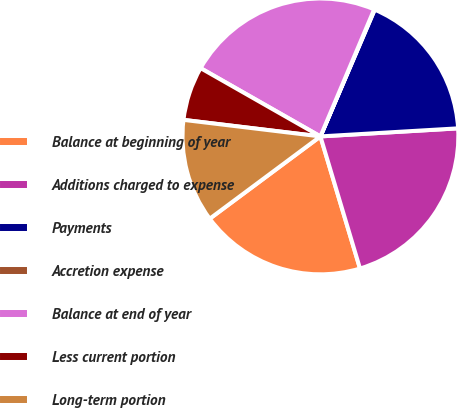<chart> <loc_0><loc_0><loc_500><loc_500><pie_chart><fcel>Balance at beginning of year<fcel>Additions charged to expense<fcel>Payments<fcel>Accretion expense<fcel>Balance at end of year<fcel>Less current portion<fcel>Long-term portion<nl><fcel>19.46%<fcel>21.3%<fcel>17.63%<fcel>0.07%<fcel>23.13%<fcel>6.33%<fcel>12.09%<nl></chart> 